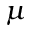Convert formula to latex. <formula><loc_0><loc_0><loc_500><loc_500>\mu</formula> 